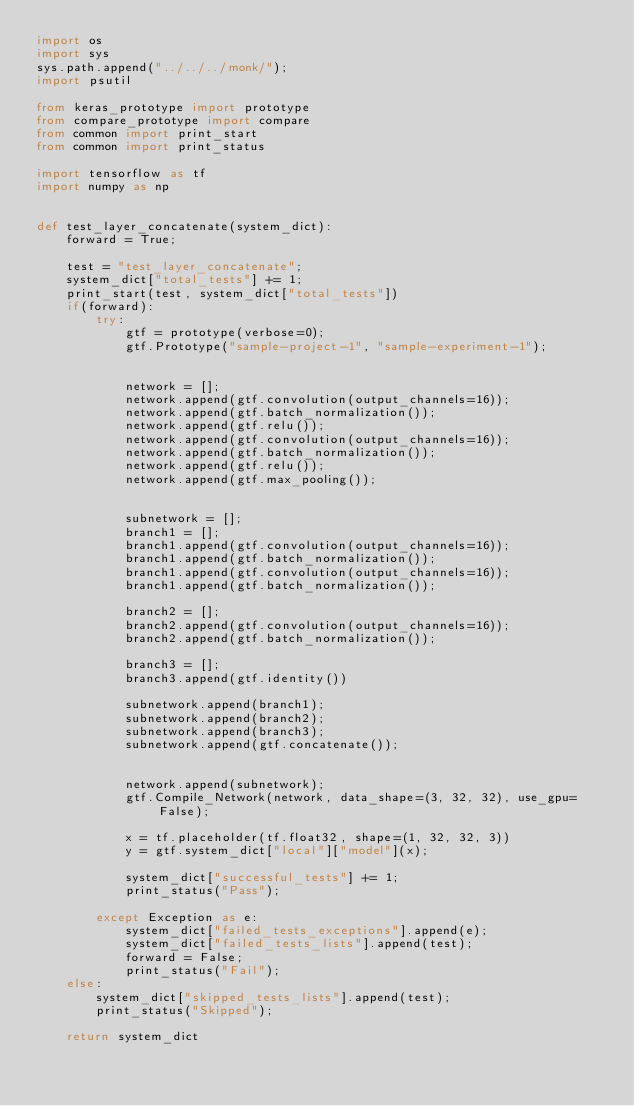<code> <loc_0><loc_0><loc_500><loc_500><_Python_>import os
import sys
sys.path.append("../../../monk/");
import psutil

from keras_prototype import prototype
from compare_prototype import compare
from common import print_start
from common import print_status

import tensorflow as tf
import numpy as np


def test_layer_concatenate(system_dict):
    forward = True;

    test = "test_layer_concatenate";
    system_dict["total_tests"] += 1;
    print_start(test, system_dict["total_tests"])
    if(forward):
        try:
            gtf = prototype(verbose=0);
            gtf.Prototype("sample-project-1", "sample-experiment-1");


            network = [];
            network.append(gtf.convolution(output_channels=16));
            network.append(gtf.batch_normalization());
            network.append(gtf.relu());
            network.append(gtf.convolution(output_channels=16));
            network.append(gtf.batch_normalization());
            network.append(gtf.relu());
            network.append(gtf.max_pooling());


            subnetwork = [];
            branch1 = [];
            branch1.append(gtf.convolution(output_channels=16));
            branch1.append(gtf.batch_normalization());
            branch1.append(gtf.convolution(output_channels=16));
            branch1.append(gtf.batch_normalization());

            branch2 = [];
            branch2.append(gtf.convolution(output_channels=16));
            branch2.append(gtf.batch_normalization());

            branch3 = [];
            branch3.append(gtf.identity())

            subnetwork.append(branch1);
            subnetwork.append(branch2);
            subnetwork.append(branch3);
            subnetwork.append(gtf.concatenate());


            network.append(subnetwork);
            gtf.Compile_Network(network, data_shape=(3, 32, 32), use_gpu=False);

            x = tf.placeholder(tf.float32, shape=(1, 32, 32, 3))
            y = gtf.system_dict["local"]["model"](x);          

            system_dict["successful_tests"] += 1;
            print_status("Pass");

        except Exception as e:
            system_dict["failed_tests_exceptions"].append(e);
            system_dict["failed_tests_lists"].append(test);
            forward = False;
            print_status("Fail");
    else:
        system_dict["skipped_tests_lists"].append(test);
        print_status("Skipped");

    return system_dict
</code> 